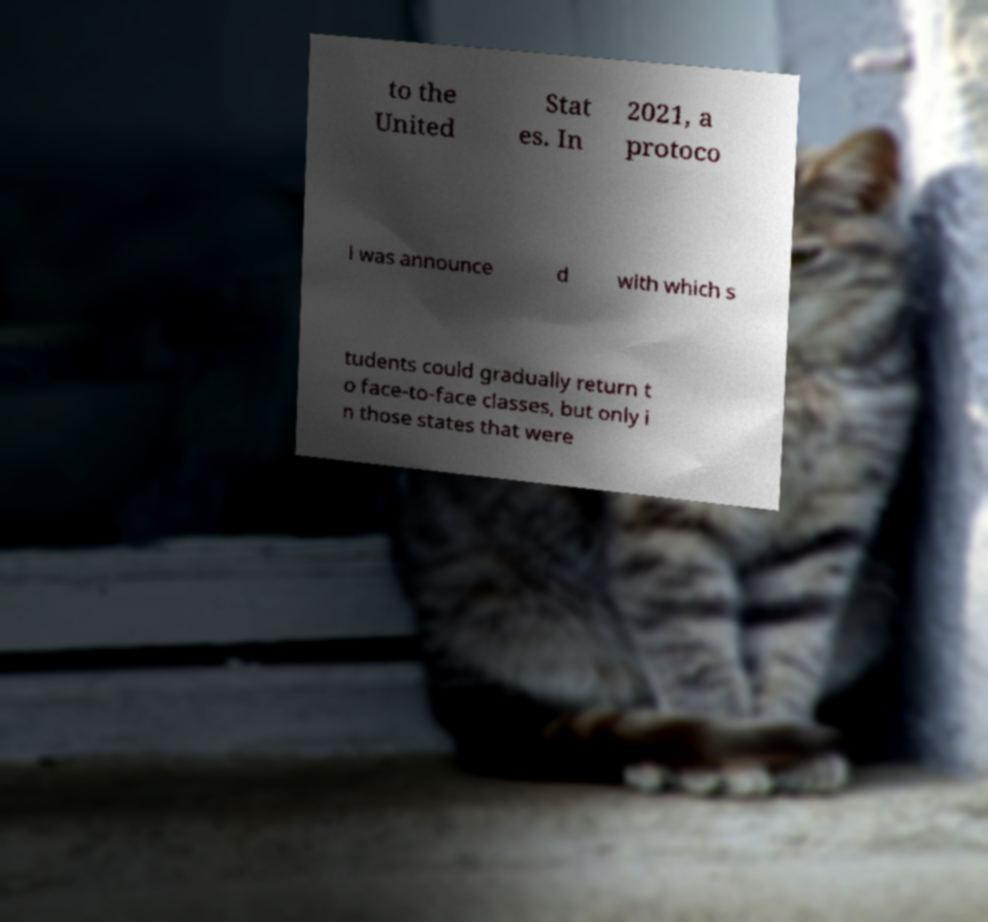What messages or text are displayed in this image? I need them in a readable, typed format. to the United Stat es. In 2021, a protoco l was announce d with which s tudents could gradually return t o face-to-face classes, but only i n those states that were 